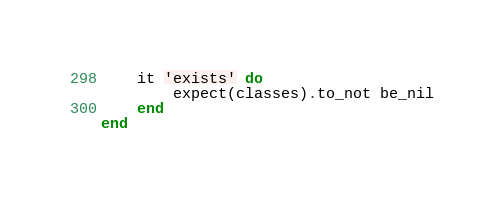Convert code to text. <code><loc_0><loc_0><loc_500><loc_500><_Ruby_>
	it 'exists' do
		expect(classes).to_not be_nil
	end
end</code> 